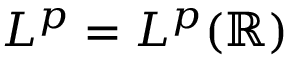<formula> <loc_0><loc_0><loc_500><loc_500>L ^ { p } = L ^ { p } ( \mathbb { R } )</formula> 